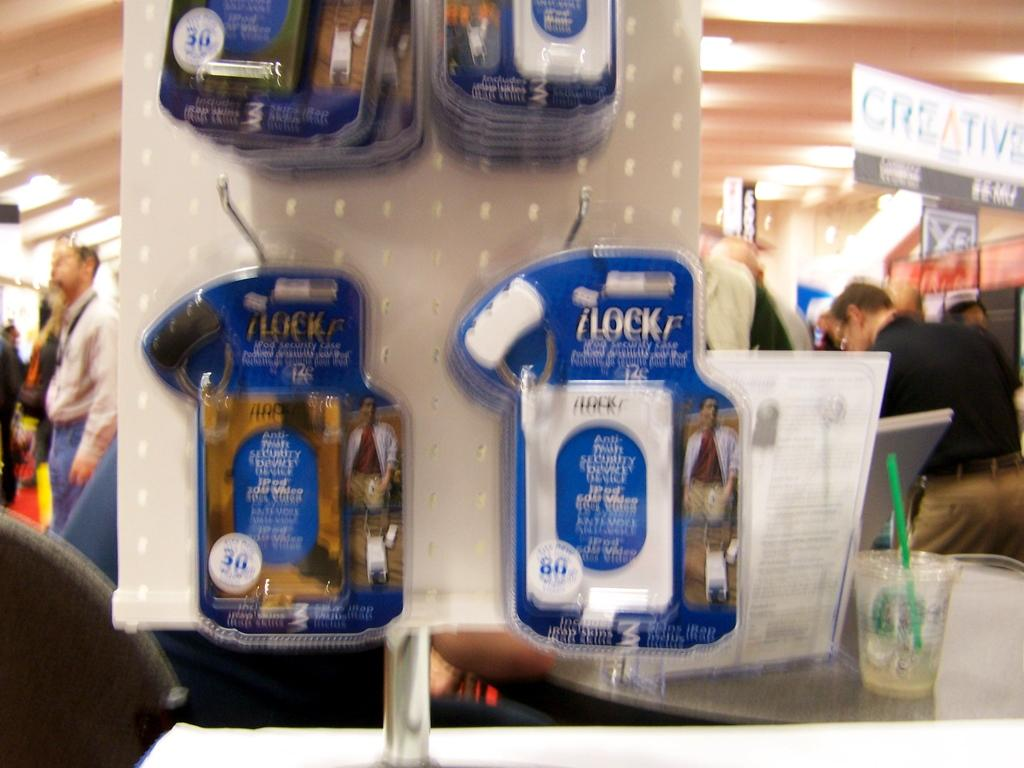What is attached to the stand in the image? There are packets attached to a stand in the image. What can be seen on a table in the image? There is a glass on a table in the image. What else is on the table in the image? There is an object on the table in the image. Who is present in the store in the image? There are people in the store in the image. What is hanging from the roof in the image? There are boards hanging from the roof in the image. What type of engine is visible in the image? There is no engine present in the image. What decision was made by the people in the store in the image? The image does not provide information about any decisions made by the people in the store. --- Facts: 1. There is a person holding a book in the image. 2. The person is sitting on a chair. 3. There is a table in front of the person. 4. The book has a yellow cover. 5. The person is wearing glasses. Absurd Topics: parrot, ocean, bicycle Conversation: What is the person holding in the image? The person is holding a book in the image. What is the person sitting on in the image? The person is sitting on a chair in the image. What is in front of the person in the image? There is a table in front of the person in the image. What color is the book's cover? The book has a yellow cover. What accessory is the person wearing in the image? The person is wearing glasses in the image. Reasoning: Let's think step by step in order to produce the conversation. We start by identifying the main subject in the image, which is the person holding a book. Then, we expand the conversation to include other items that are also visible, such as the chair, table, and the person's glasses. Each question is designed to elicit a specific detail about the image that is known from the provided facts. Absurd Question/Answer: Can you see a parrot sitting on the person's shoulder in the image? No, there is no parrot present in the image. What type of ocean can be seen in the background of the image? There is no ocean visible in the image. 